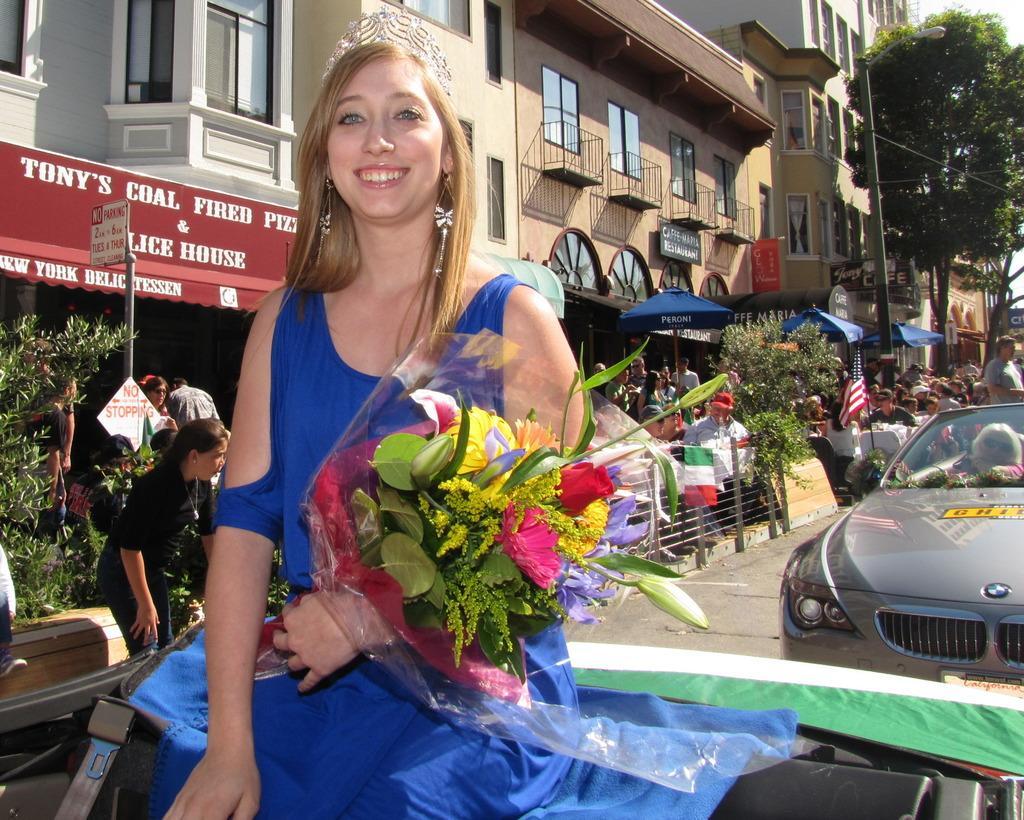How would you summarize this image in a sentence or two? In this image, we can see a woman is sitting and holding a bouquet. She is watching and smiling. Background we can see so many people, plants, rods, poles, sign boards, umbrellas, buildings, walls, windows, trees, banners and flag. Right side of the image, there is a vehicle on the road. 